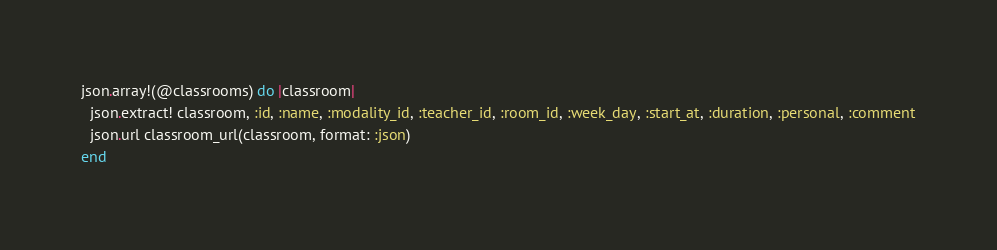<code> <loc_0><loc_0><loc_500><loc_500><_Ruby_>json.array!(@classrooms) do |classroom|
  json.extract! classroom, :id, :name, :modality_id, :teacher_id, :room_id, :week_day, :start_at, :duration, :personal, :comment
  json.url classroom_url(classroom, format: :json)
end
</code> 